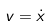<formula> <loc_0><loc_0><loc_500><loc_500>v = \dot { x }</formula> 